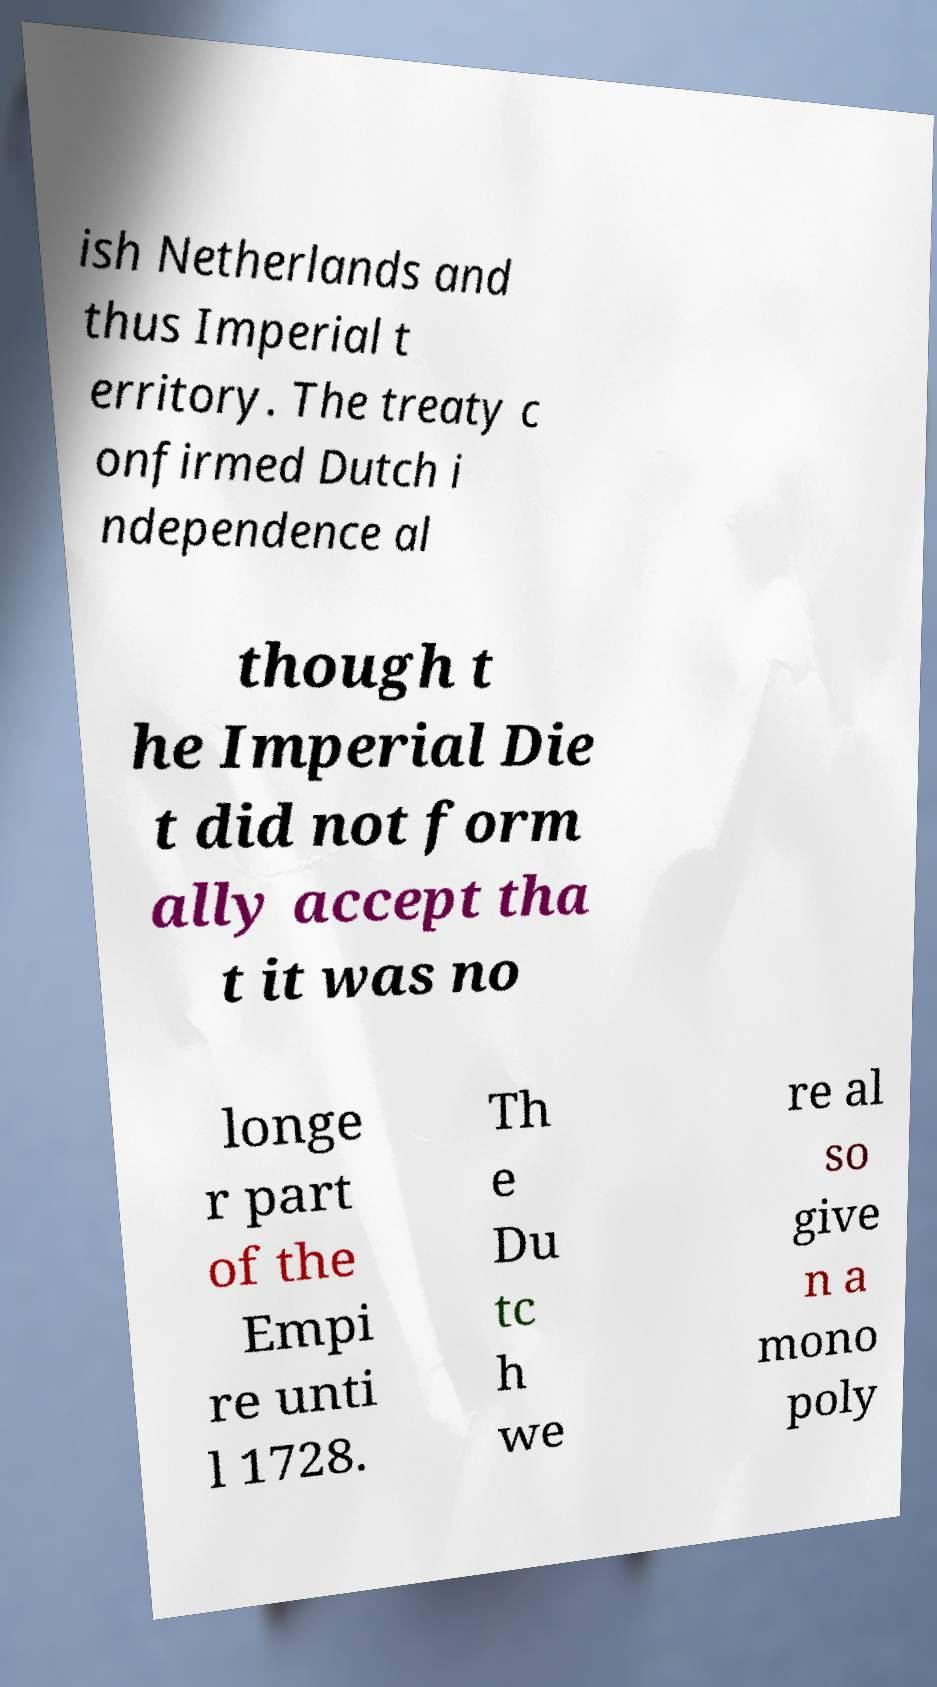For documentation purposes, I need the text within this image transcribed. Could you provide that? ish Netherlands and thus Imperial t erritory. The treaty c onfirmed Dutch i ndependence al though t he Imperial Die t did not form ally accept tha t it was no longe r part of the Empi re unti l 1728. Th e Du tc h we re al so give n a mono poly 